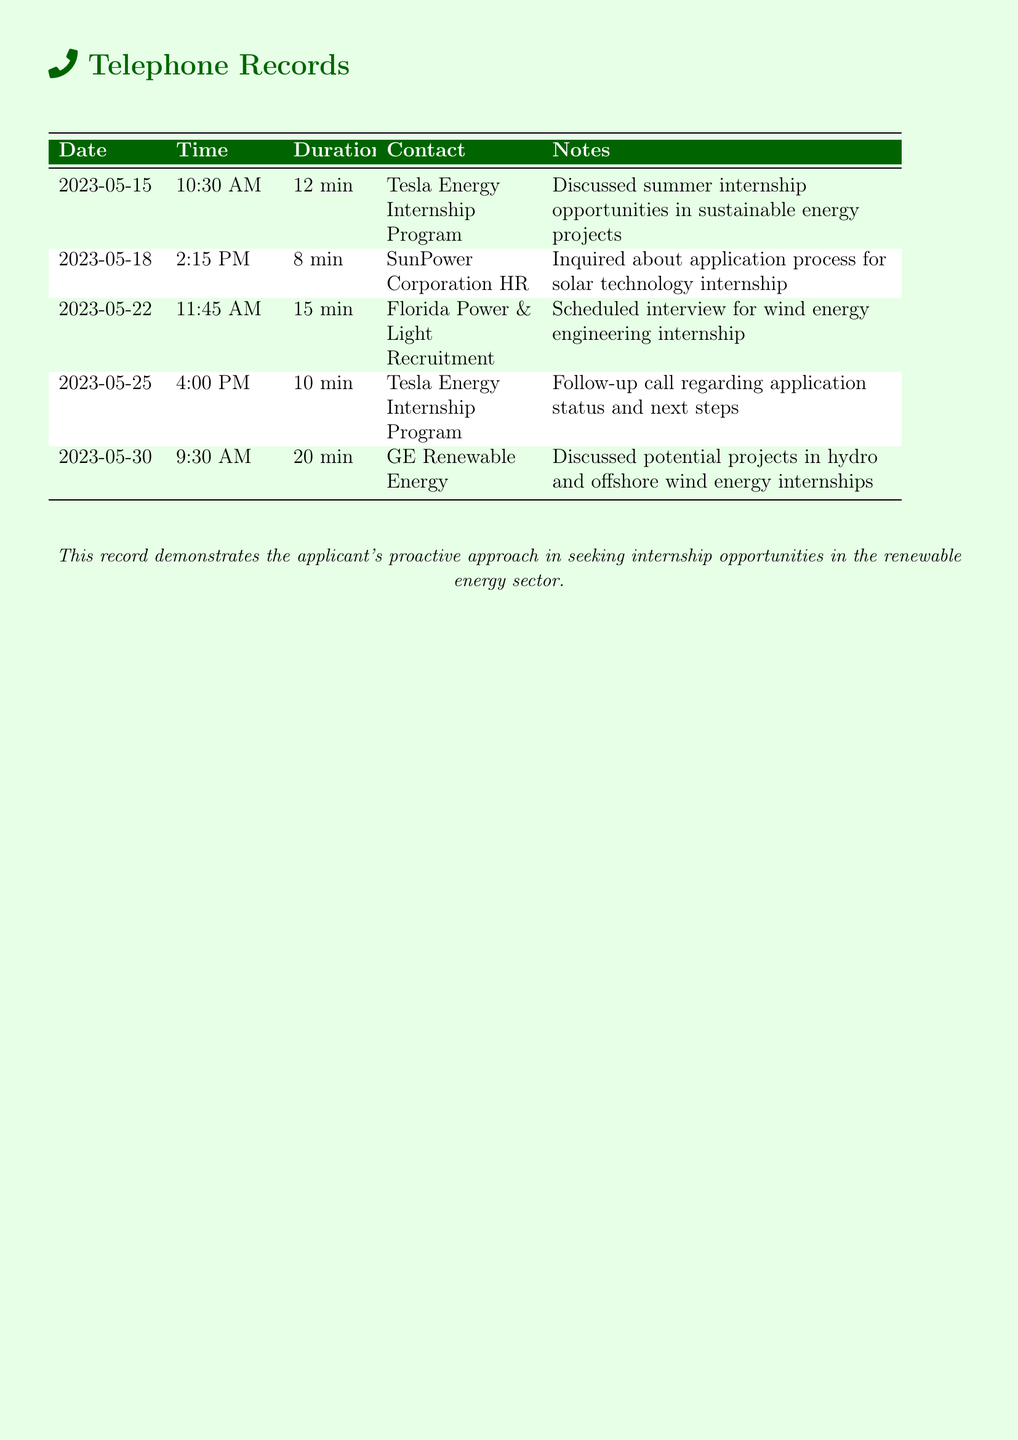What is the date of the first call? The first call recorded in the document took place on May 15, 2023.
Answer: May 15, 2023 Who was the contact for the second call? The second call was with the HR department of SunPower Corporation.
Answer: SunPower Corporation HR How long did the call with GE Renewable Energy last? The duration of the call with GE Renewable Energy was 20 minutes.
Answer: 20 min What was discussed in the call on May 30? The call on May 30 discussed potential projects in hydro and offshore wind energy internships.
Answer: Potential projects in hydro and offshore wind energy internships How many different companies were contacted regarding internships? The document lists three different companies contacted for internships.
Answer: Three What was the purpose of the follow-up call on May 25? The follow-up call was regarding the application status and next steps.
Answer: Application status and next steps Which internship had an interview scheduled? An interview was scheduled for the wind energy engineering internship.
Answer: Wind energy engineering internship What was the duration of the call with Tesla Energy on May 15? The call with Tesla Energy on May 15 lasted for 12 minutes.
Answer: 12 min 